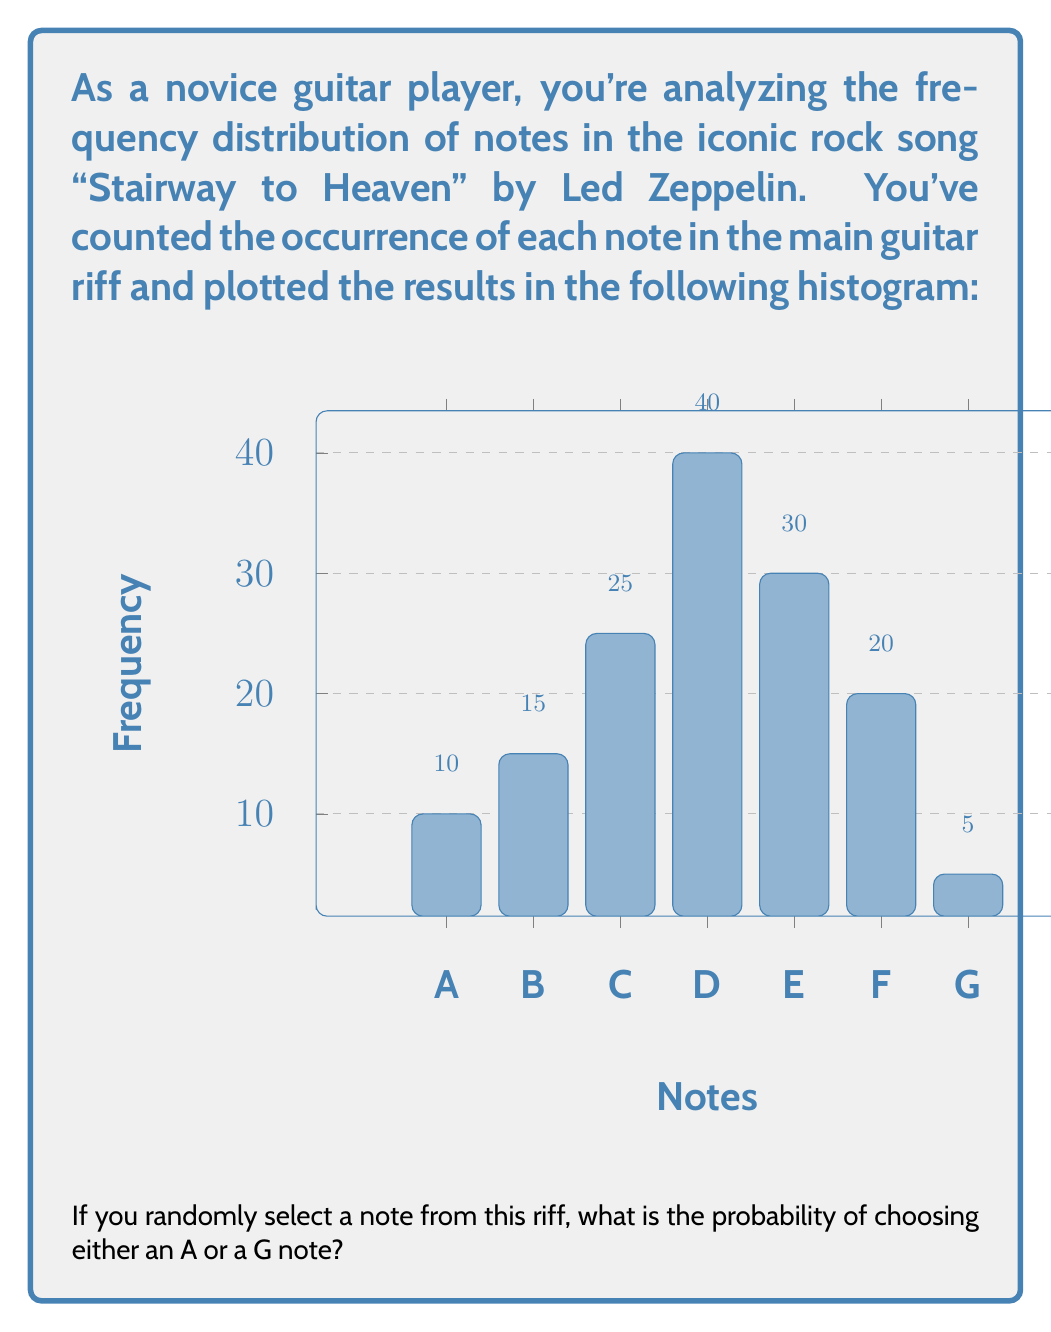What is the answer to this math problem? To solve this problem, we need to follow these steps:

1. Calculate the total number of notes in the riff:
   $10 + 15 + 25 + 40 + 30 + 20 + 5 = 145$ total notes

2. Identify the number of A and G notes:
   A: 10 notes
   G: 5 notes

3. Calculate the probability of selecting either an A or a G note:
   $$P(A \text{ or } G) = \frac{\text{Number of favorable outcomes}}{\text{Total number of possible outcomes}}$$
   $$P(A \text{ or } G) = \frac{\text{Number of A notes} + \text{Number of G notes}}{\text{Total number of notes}}$$
   $$P(A \text{ or } G) = \frac{10 + 5}{145} = \frac{15}{145}$$

4. Simplify the fraction:
   $$\frac{15}{145} = \frac{3}{29} \approx 0.1034 \text{ or } 10.34\%$$

Therefore, the probability of randomly selecting either an A or a G note from this riff is $\frac{3}{29}$.
Answer: $\frac{3}{29}$ 